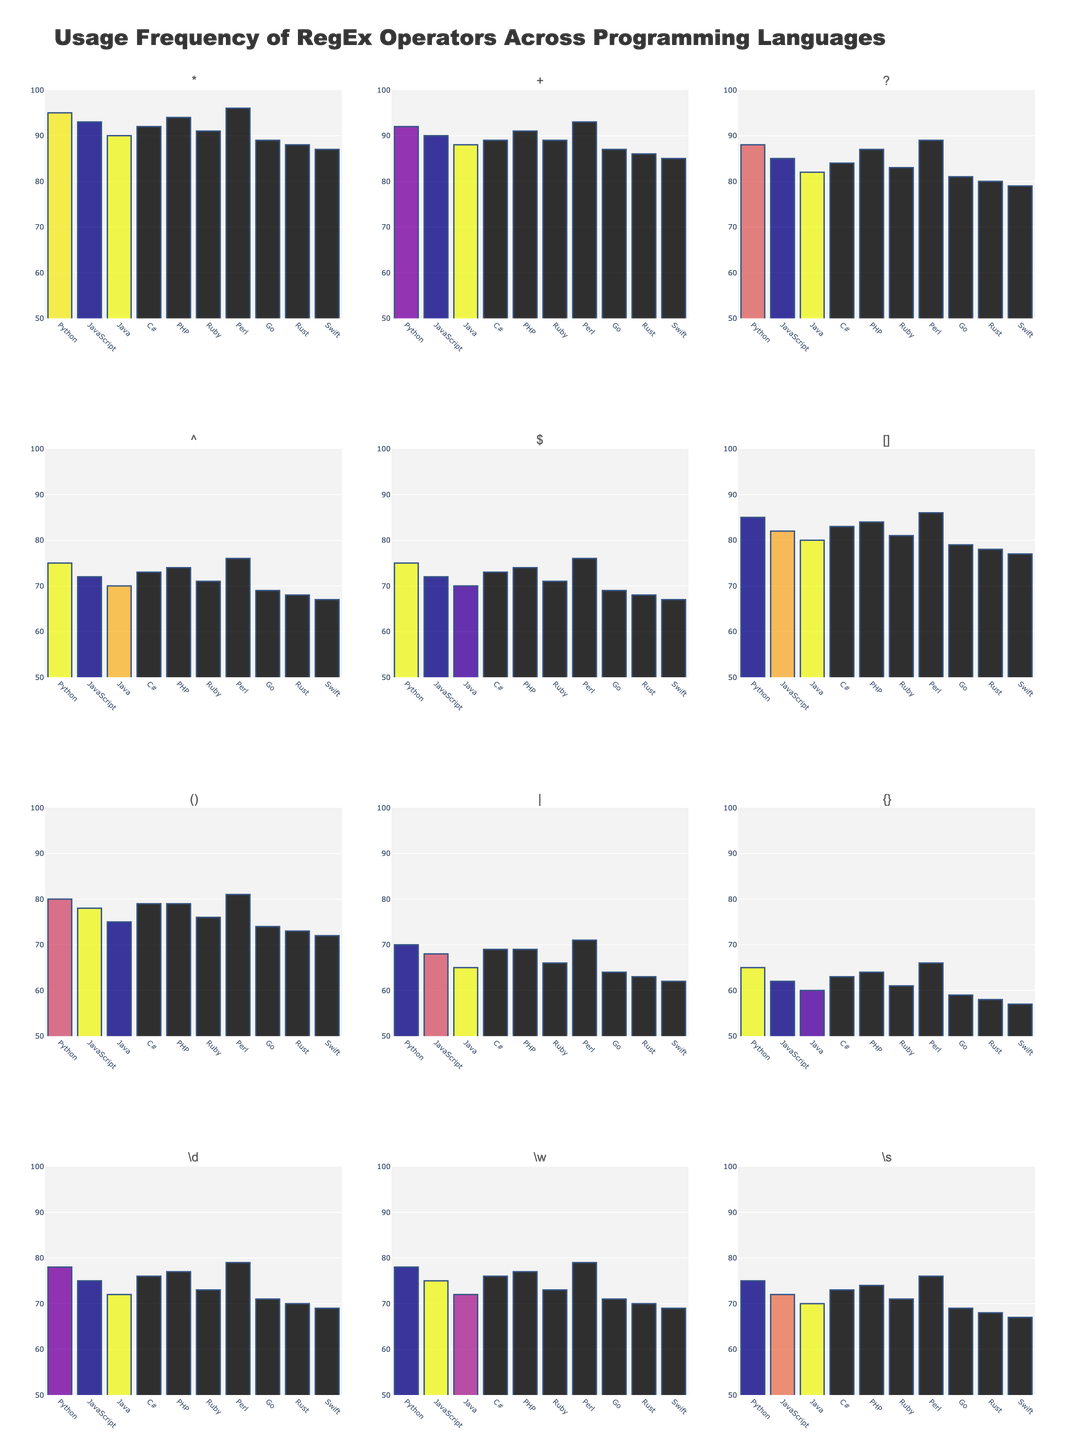What is the most frequently used regular expression operator in Python? The bar chart for Python shows the height of each bar representing the usage frequency of various operators. The bar corresponding to '*' is the tallest.
Answer: * Which language uses the '\d' operator with the same frequency? Both Python and Perl have bars for the '\d' operator at the same height, indicating equal usage frequency. These bars are the third from the right on the respective subplots.
Answer: Python and Perl Which operator has the highest average usage across all programming languages? To find the average, sum the frequencies of each operator for all languages and then divide by the number of languages. The '*' operator has the highest bar heights on average across all languages.
Answer: * How does the usage frequency of the '+' operator in Java compare to that in JavaScript? By comparing the heights of the bars for the '+' operator in the Java and JavaScript subplots, we can see that Java has a slightly lower usage frequency than JavaScript.
Answer: JavaScript uses it more Which operator shows the least variation in usage frequency across all languages? The operator with bars of almost equal heights in all subplots indicates the least variation. The '^' operator has nearly consistent bar heights across languages.
Answer: ^ Is the usage frequency of the '[]' operator in Ruby greater than in Go? By comparing the height of the '[]' operator bar in the Ruby subplot with the one in the Go subplot, Ruby's bar is taller, indicating a higher usage frequency.
Answer: Yes How does the usage frequency of the '()' operator in C# compare to its usage in Rust? The height of the bars for the '()' operator in the C# and Rust subplots shows that C# has a higher frequency than Rust.
Answer: C# uses it more Which language has the lowest usage frequency for the '$' operator? The bar for the '$' operator in the Swift subplot is the shortest among all languages for this operator, indicating the lowest usage frequency.
Answer: Swift What is the difference in usage frequency of the '\w' operator between Perl and Swift? Subtract the height of the '\w' operator bar in the Swift subplot from that in the Perl subplot: 79 (Perl) - 69 (Swift) = 10.
Answer: 10 